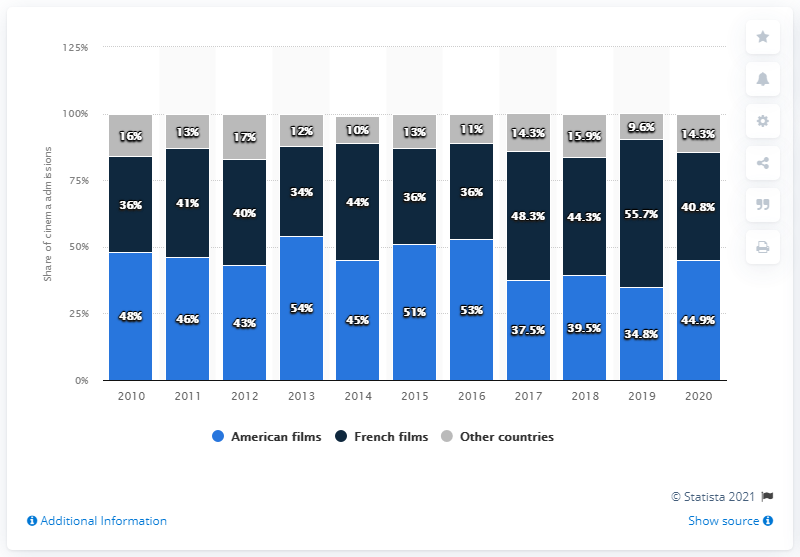Highlight a few significant elements in this photo. The average grade awarded to French films in the last two years is 48.25. The highest percentage value in the blue bar is 54%. 